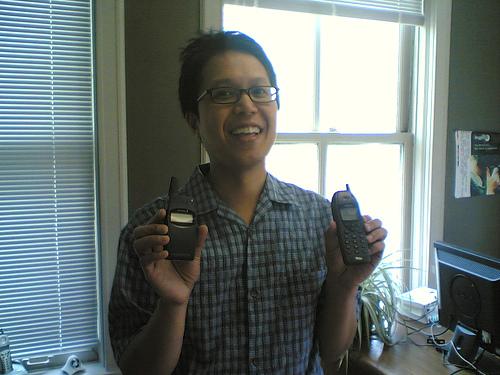Is the cell phone silver?
Short answer required. No. How many phones?
Quick response, please. 2. How many panes of glass are in the uncovered window?
Quick response, please. 4. Is the computer from the 1980s?
Give a very brief answer. No. 